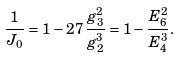<formula> <loc_0><loc_0><loc_500><loc_500>\frac { 1 } { J _ { 0 } } = 1 - 2 7 \, \frac { g _ { 3 } ^ { 2 } } { g _ { 2 } ^ { 3 } } = 1 - \frac { E _ { 6 } ^ { 2 } } { E _ { 4 } ^ { 3 } } .</formula> 